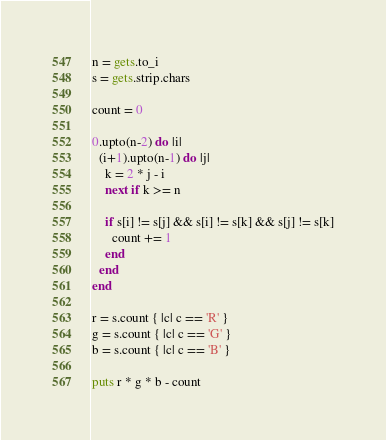<code> <loc_0><loc_0><loc_500><loc_500><_Ruby_>n = gets.to_i
s = gets.strip.chars
 
count = 0
 
0.upto(n-2) do |i|
  (i+1).upto(n-1) do |j|
    k = 2 * j - i
    next if k >= n
 
    if s[i] != s[j] && s[i] != s[k] && s[j] != s[k]
      count += 1
    end
  end
end
 
r = s.count { |c| c == 'R' }
g = s.count { |c| c == 'G' }
b = s.count { |c| c == 'B' }
 
puts r * g * b - count</code> 